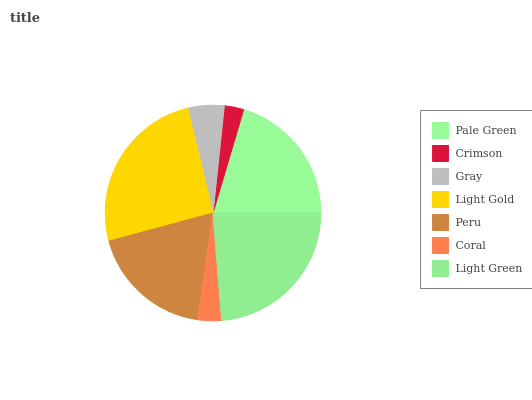Is Crimson the minimum?
Answer yes or no. Yes. Is Light Gold the maximum?
Answer yes or no. Yes. Is Gray the minimum?
Answer yes or no. No. Is Gray the maximum?
Answer yes or no. No. Is Gray greater than Crimson?
Answer yes or no. Yes. Is Crimson less than Gray?
Answer yes or no. Yes. Is Crimson greater than Gray?
Answer yes or no. No. Is Gray less than Crimson?
Answer yes or no. No. Is Peru the high median?
Answer yes or no. Yes. Is Peru the low median?
Answer yes or no. Yes. Is Coral the high median?
Answer yes or no. No. Is Light Gold the low median?
Answer yes or no. No. 